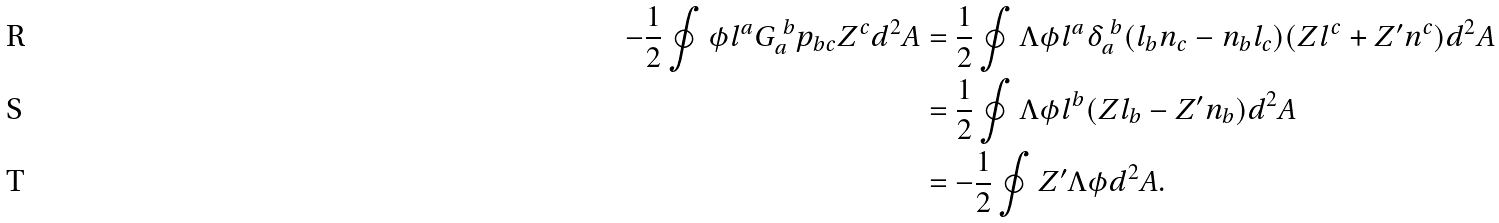<formula> <loc_0><loc_0><loc_500><loc_500>- \frac { 1 } { 2 } \oint { \phi l ^ { a } G _ { a } ^ { \ b } p _ { b c } Z ^ { c } d ^ { 2 } A } & = \frac { 1 } { 2 } \oint { \Lambda \phi l ^ { a } \delta _ { a } ^ { \ b } ( l _ { b } n _ { c } - n _ { b } l _ { c } ) ( Z l ^ { c } + Z ^ { \prime } n ^ { c } ) d ^ { 2 } A } \\ & = \frac { 1 } { 2 } \oint { \Lambda \phi l ^ { b } ( Z l _ { b } - Z ^ { \prime } n _ { b } ) d ^ { 2 } A } \\ & = - \frac { 1 } { 2 } \oint { Z ^ { \prime } \Lambda \phi d ^ { 2 } A } .</formula> 